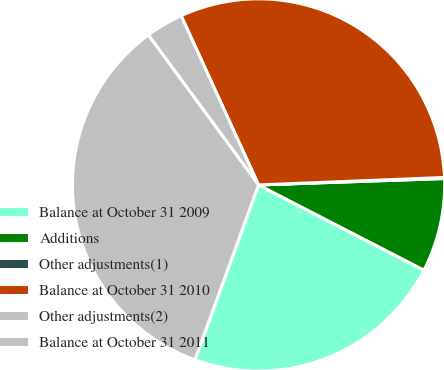Convert chart to OTSL. <chart><loc_0><loc_0><loc_500><loc_500><pie_chart><fcel>Balance at October 31 2009<fcel>Additions<fcel>Other adjustments(1)<fcel>Balance at October 31 2010<fcel>Other adjustments(2)<fcel>Balance at October 31 2011<nl><fcel>22.98%<fcel>8.12%<fcel>0.09%<fcel>31.19%<fcel>3.26%<fcel>34.36%<nl></chart> 